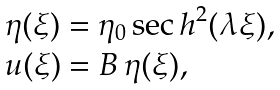<formula> <loc_0><loc_0><loc_500><loc_500>\begin{array} { l } \eta ( \xi ) = \eta _ { 0 } \, { \sec h } ^ { 2 } ( \lambda \xi ) , \\ u ( \xi ) = B \, \eta ( \xi ) , \end{array}</formula> 